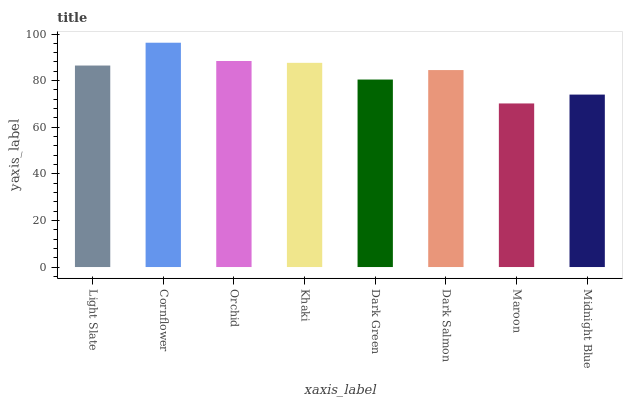Is Maroon the minimum?
Answer yes or no. Yes. Is Cornflower the maximum?
Answer yes or no. Yes. Is Orchid the minimum?
Answer yes or no. No. Is Orchid the maximum?
Answer yes or no. No. Is Cornflower greater than Orchid?
Answer yes or no. Yes. Is Orchid less than Cornflower?
Answer yes or no. Yes. Is Orchid greater than Cornflower?
Answer yes or no. No. Is Cornflower less than Orchid?
Answer yes or no. No. Is Light Slate the high median?
Answer yes or no. Yes. Is Dark Salmon the low median?
Answer yes or no. Yes. Is Dark Salmon the high median?
Answer yes or no. No. Is Maroon the low median?
Answer yes or no. No. 